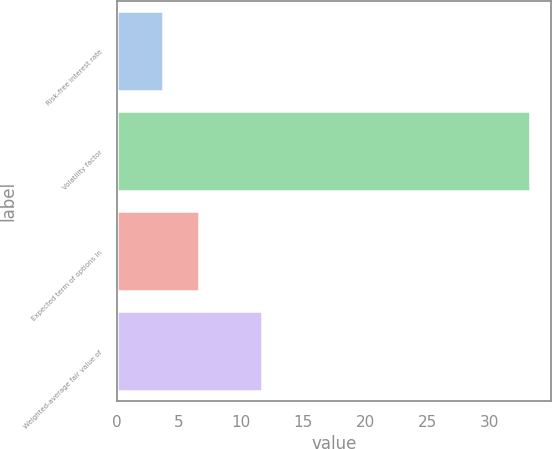<chart> <loc_0><loc_0><loc_500><loc_500><bar_chart><fcel>Risk-free interest rate<fcel>Volatility factor<fcel>Expected term of options in<fcel>Weighted-average fair value of<nl><fcel>3.69<fcel>33.26<fcel>6.65<fcel>11.66<nl></chart> 